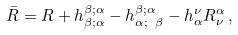<formula> <loc_0><loc_0><loc_500><loc_500>\bar { R } = R + h _ { \beta ; \alpha } ^ { \beta ; \alpha } - h _ { \alpha ; \ \beta } ^ { \beta ; \alpha } - h ^ { \nu } _ { \alpha } R ^ { \alpha } _ { \nu } \, ,</formula> 